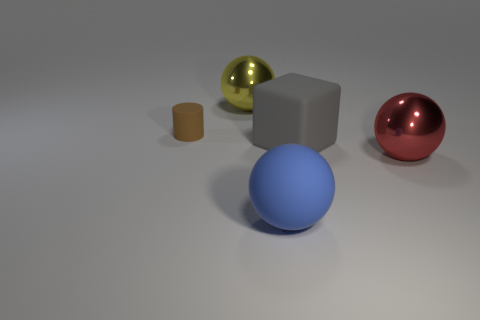Subtract all metal balls. How many balls are left? 1 Add 1 gray objects. How many objects exist? 6 Subtract all cylinders. How many objects are left? 4 Subtract all purple matte things. Subtract all cylinders. How many objects are left? 4 Add 3 big yellow metal spheres. How many big yellow metal spheres are left? 4 Add 4 small red cubes. How many small red cubes exist? 4 Subtract 0 green cylinders. How many objects are left? 5 Subtract 1 blocks. How many blocks are left? 0 Subtract all purple cylinders. Subtract all purple balls. How many cylinders are left? 1 Subtract all cyan cylinders. How many gray balls are left? 0 